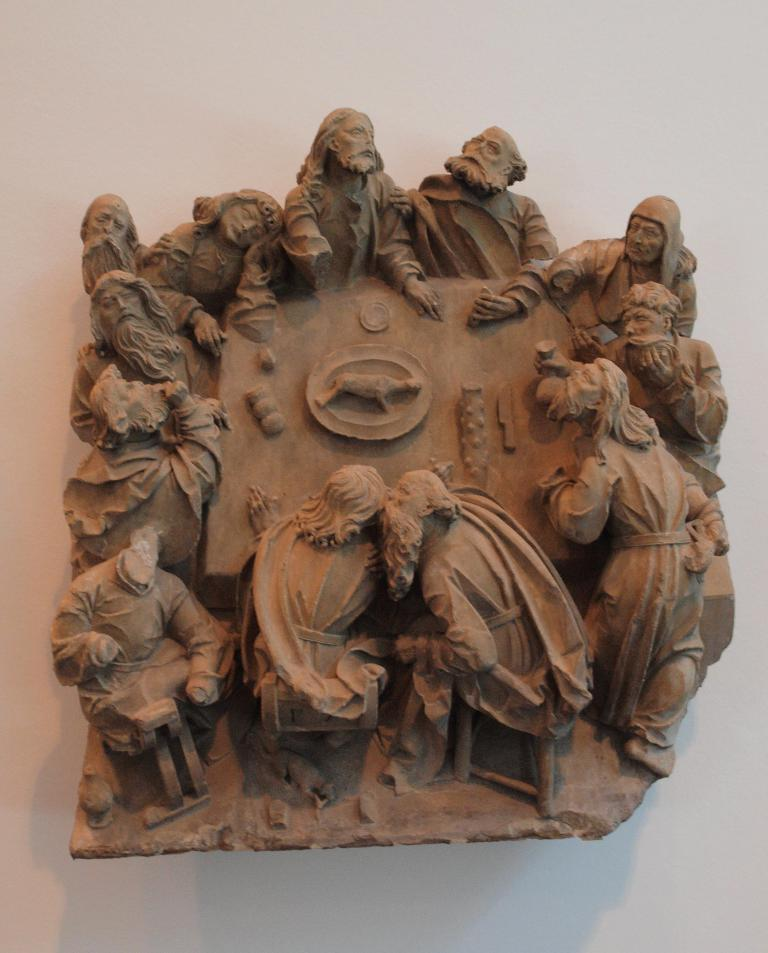What is the main subject of the image? There is a statue in the image. Where is the statue located? The statue is present on a wall. What type of board is being used for teaching in the image? There is no board or teaching activity present in the image; it features a statue on a wall. 